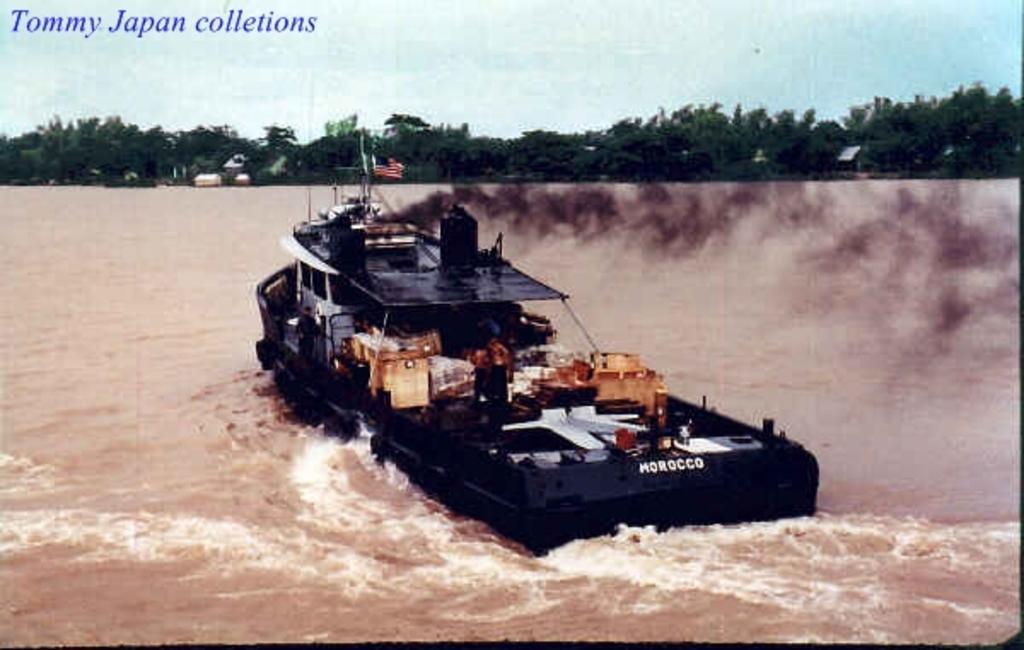Could you give a brief overview of what you see in this image? In this image I can see the boat on the water. The boat is in black color. In the back I can see many trees and the sky. I can also see the watermark in the image. 